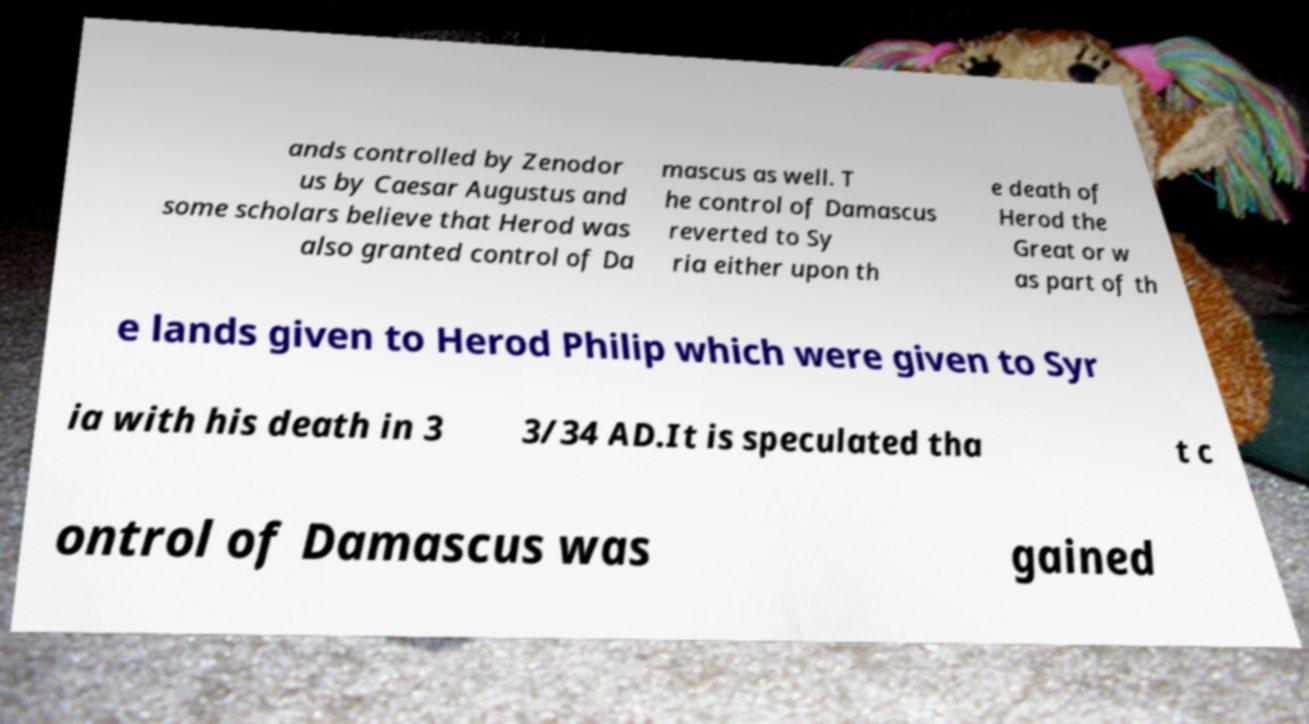Can you accurately transcribe the text from the provided image for me? ands controlled by Zenodor us by Caesar Augustus and some scholars believe that Herod was also granted control of Da mascus as well. T he control of Damascus reverted to Sy ria either upon th e death of Herod the Great or w as part of th e lands given to Herod Philip which were given to Syr ia with his death in 3 3/34 AD.It is speculated tha t c ontrol of Damascus was gained 